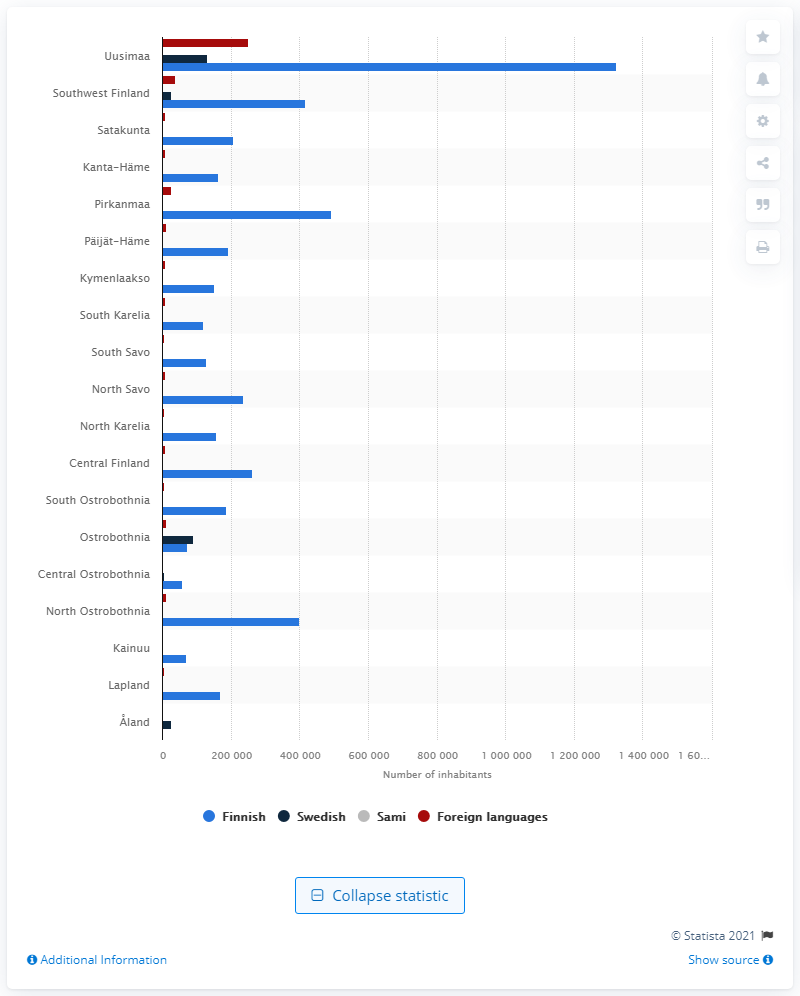Highlight a few significant elements in this photo. The largest groups of non-Finnish speaking people lived in Uusimaa, Finland. In the year 2020, it is estimated that 259,862 people with Swedish as their first language lived in land. According to the information provided, there are 1321843 Finnish speakers living in Uusimaa. 